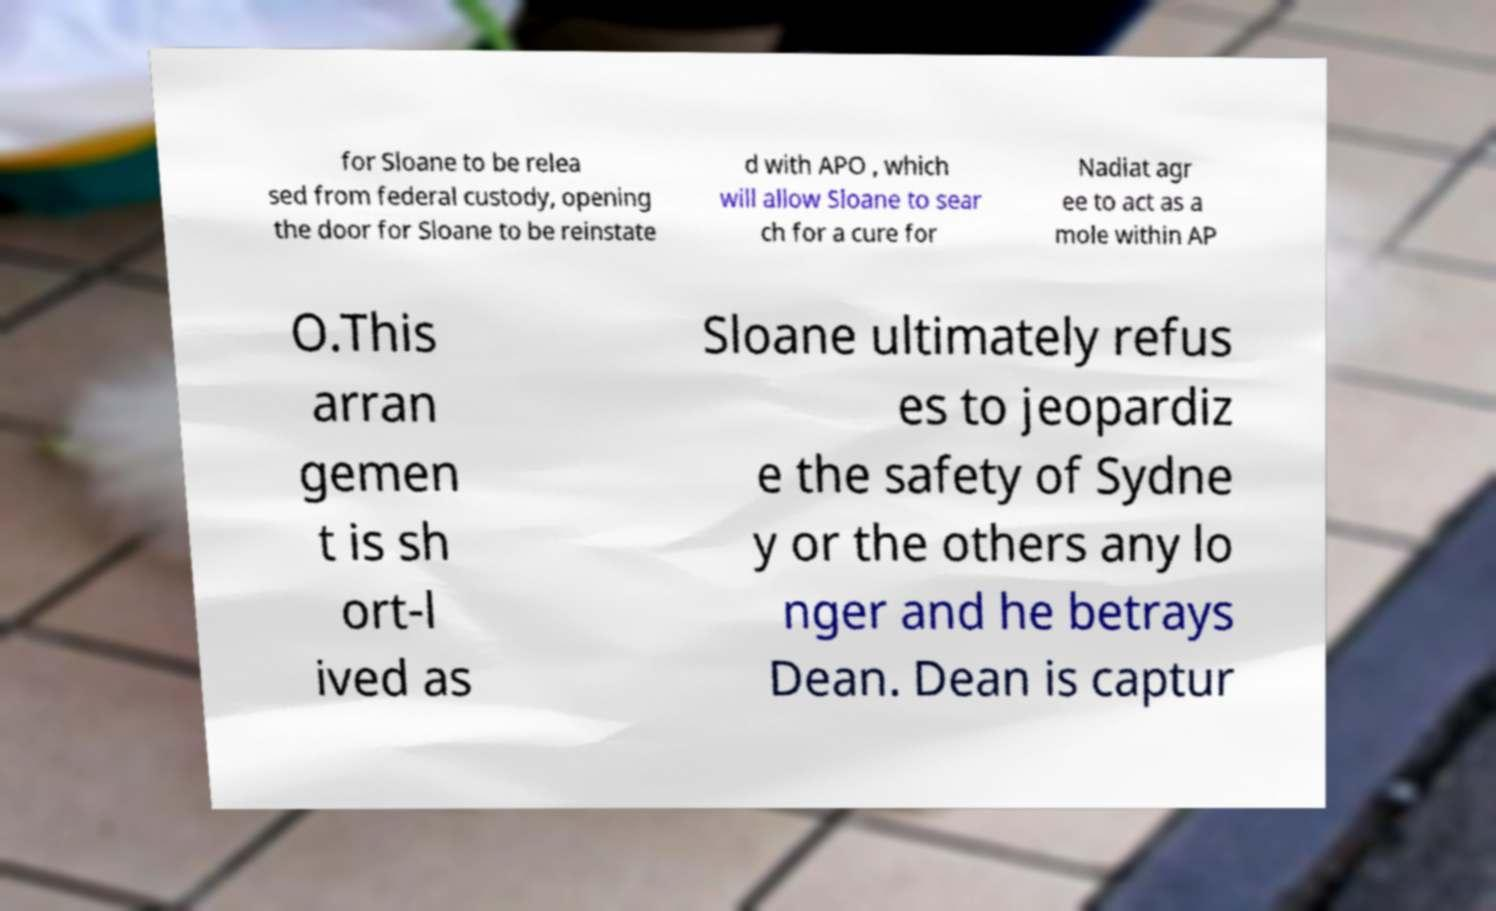Could you assist in decoding the text presented in this image and type it out clearly? for Sloane to be relea sed from federal custody, opening the door for Sloane to be reinstate d with APO , which will allow Sloane to sear ch for a cure for Nadiat agr ee to act as a mole within AP O.This arran gemen t is sh ort-l ived as Sloane ultimately refus es to jeopardiz e the safety of Sydne y or the others any lo nger and he betrays Dean. Dean is captur 